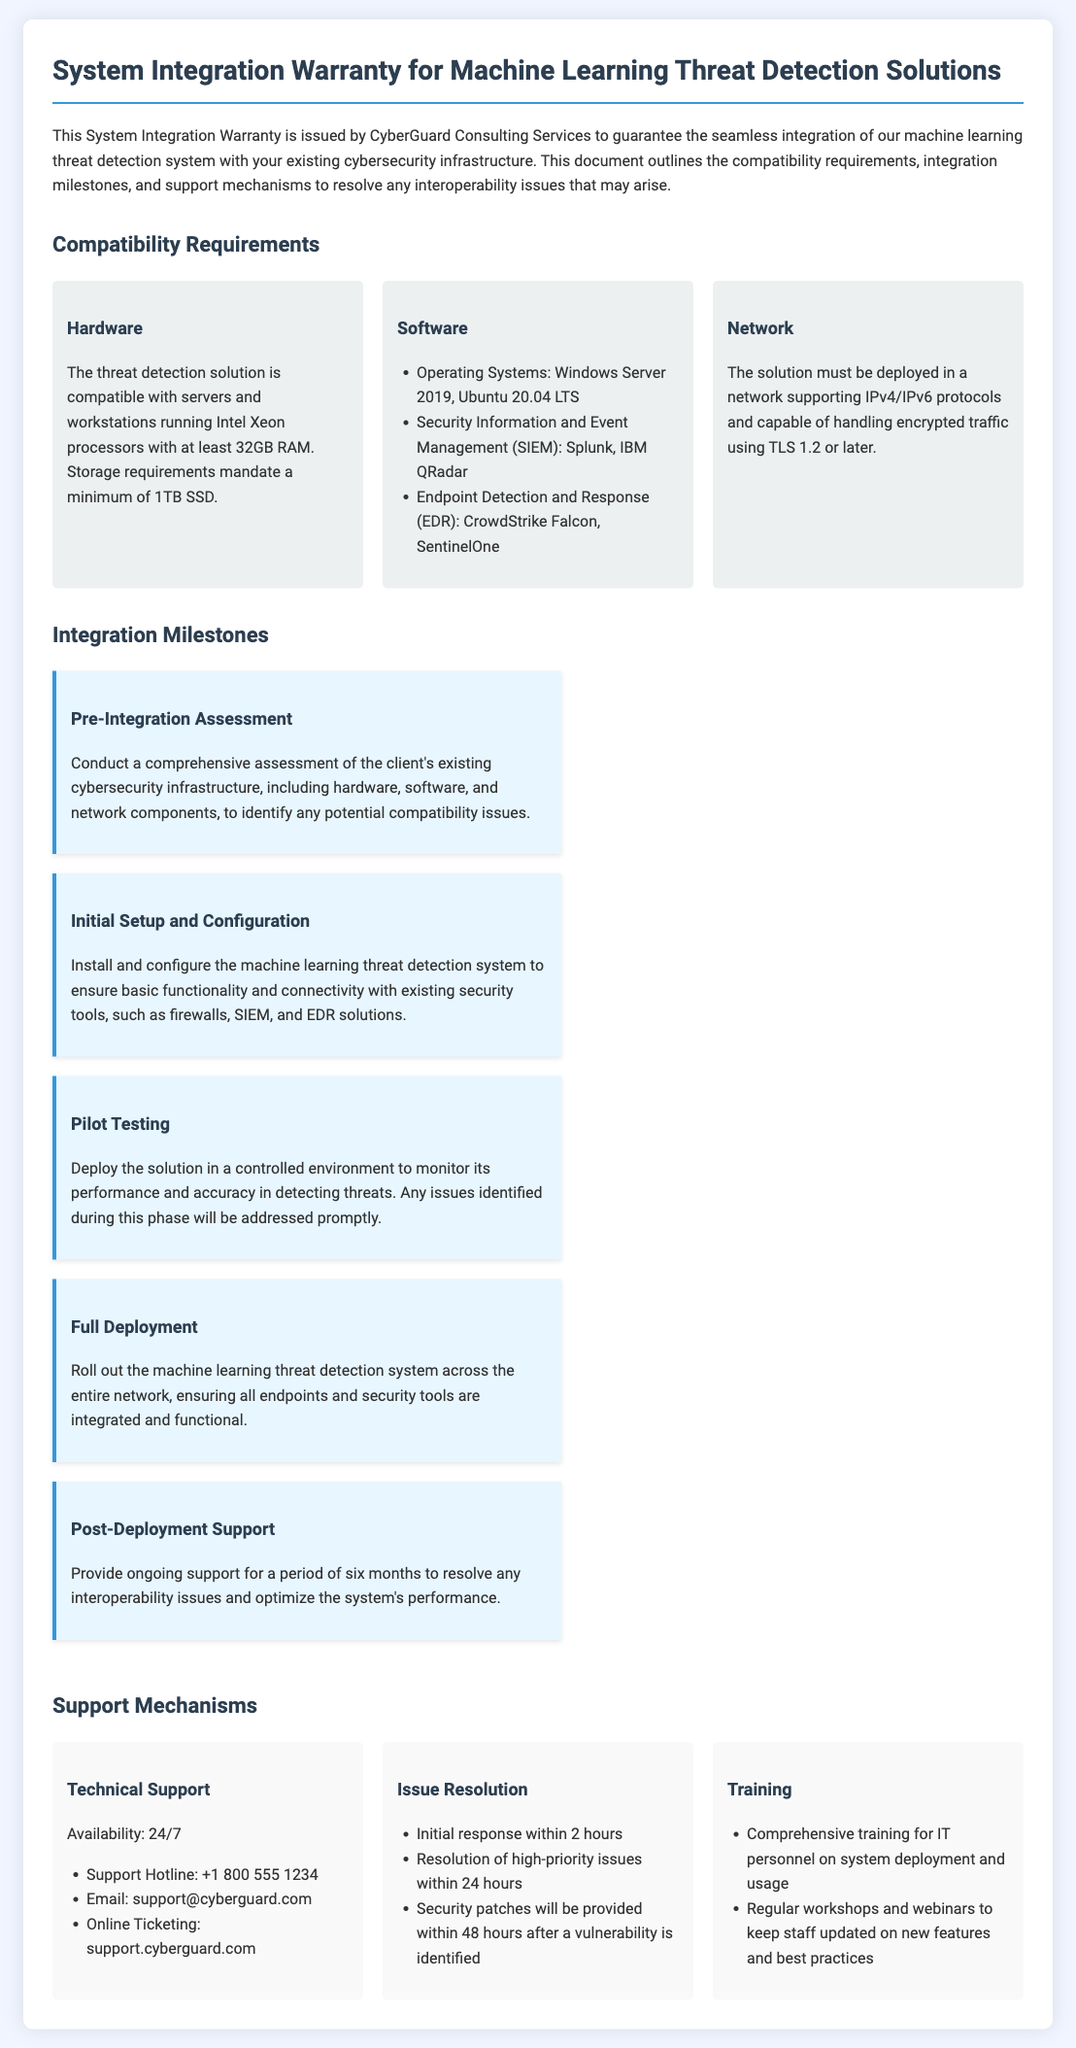What is the minimum RAM required for compatibility? The document specifies that the minimum RAM required is 32GB.
Answer: 32GB What operating systems are supported? The supported operating systems listed are Windows Server 2019 and Ubuntu 20.04 LTS.
Answer: Windows Server 2019, Ubuntu 20.04 LTS How long is the post-deployment support period? The post-deployment support period mentioned in the document is six months.
Answer: Six months What is the initial response time for technical support? The document states that the initial response time for technical support is within 2 hours.
Answer: 2 hours What is the minimum storage requirement? The document indicates that a minimum of 1TB SSD is required for compatibility.
Answer: 1TB SSD How many milestones are listed for integration? The document lists five milestones for integration.
Answer: Five What is the contact method for online support? The online support method provided in the document is through support.cyberguard.com.
Answer: support.cyberguard.com What should be done during the pre-integration assessment? The document specifies conducting a comprehensive assessment of the existing cybersecurity infrastructure.
Answer: Comprehensive assessment of infrastructure What does EDR stand for in the software compatibility section? The term EDR in the document stands for Endpoint Detection and Response.
Answer: Endpoint Detection and Response 